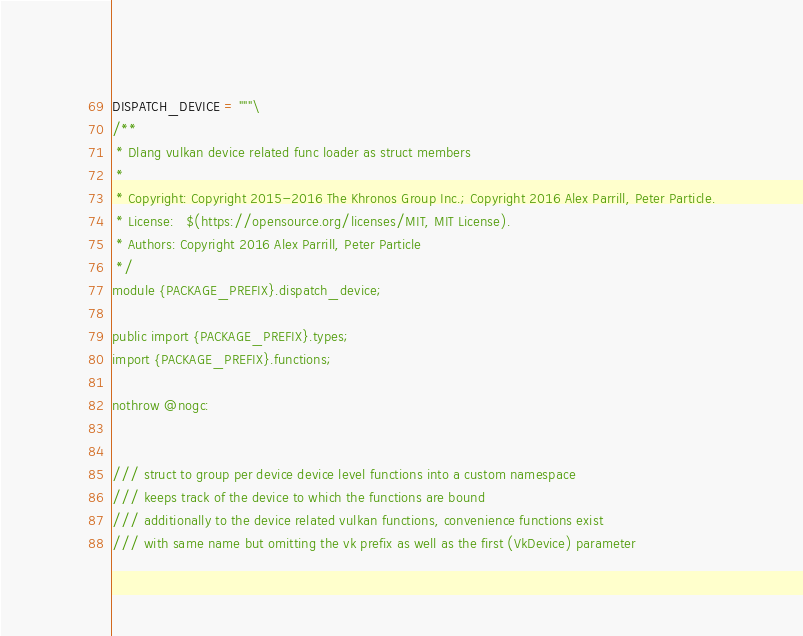<code> <loc_0><loc_0><loc_500><loc_500><_Python_>DISPATCH_DEVICE = """\
/**
 * Dlang vulkan device related func loader as struct members
 *
 * Copyright: Copyright 2015-2016 The Khronos Group Inc.; Copyright 2016 Alex Parrill, Peter Particle.
 * License:   $(https://opensource.org/licenses/MIT, MIT License).
 * Authors: Copyright 2016 Alex Parrill, Peter Particle
 */
module {PACKAGE_PREFIX}.dispatch_device;

public import {PACKAGE_PREFIX}.types;
import {PACKAGE_PREFIX}.functions;

nothrow @nogc:


/// struct to group per device device level functions into a custom namespace
/// keeps track of the device to which the functions are bound
/// additionally to the device related vulkan functions, convenience functions exist
/// with same name but omitting the vk prefix as well as the first (VkDevice) parameter</code> 